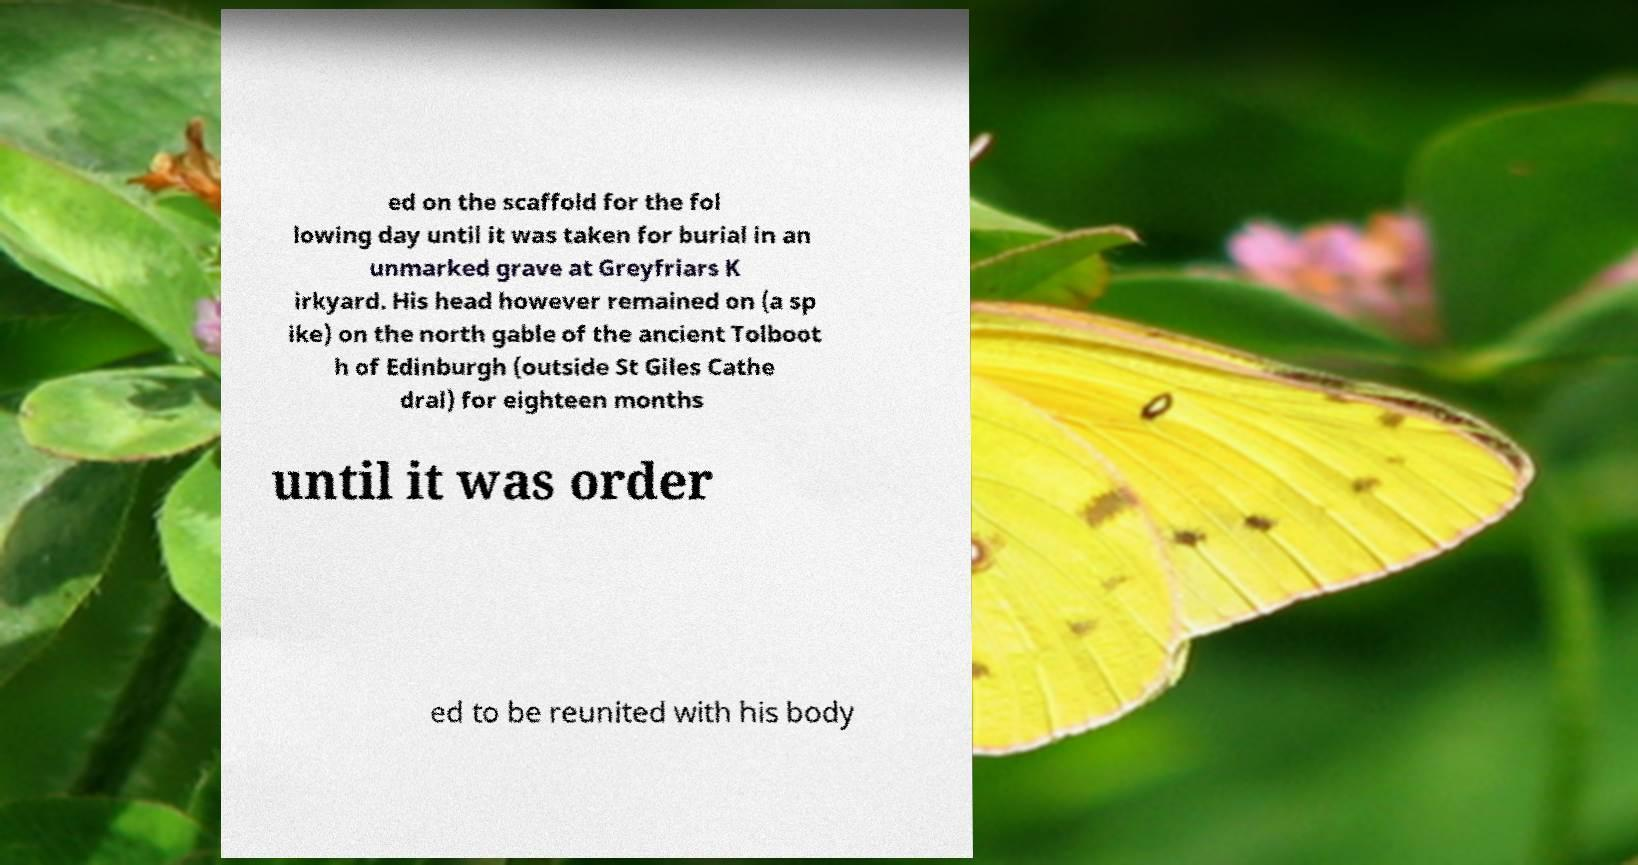Could you assist in decoding the text presented in this image and type it out clearly? ed on the scaffold for the fol lowing day until it was taken for burial in an unmarked grave at Greyfriars K irkyard. His head however remained on (a sp ike) on the north gable of the ancient Tolboot h of Edinburgh (outside St Giles Cathe dral) for eighteen months until it was order ed to be reunited with his body 